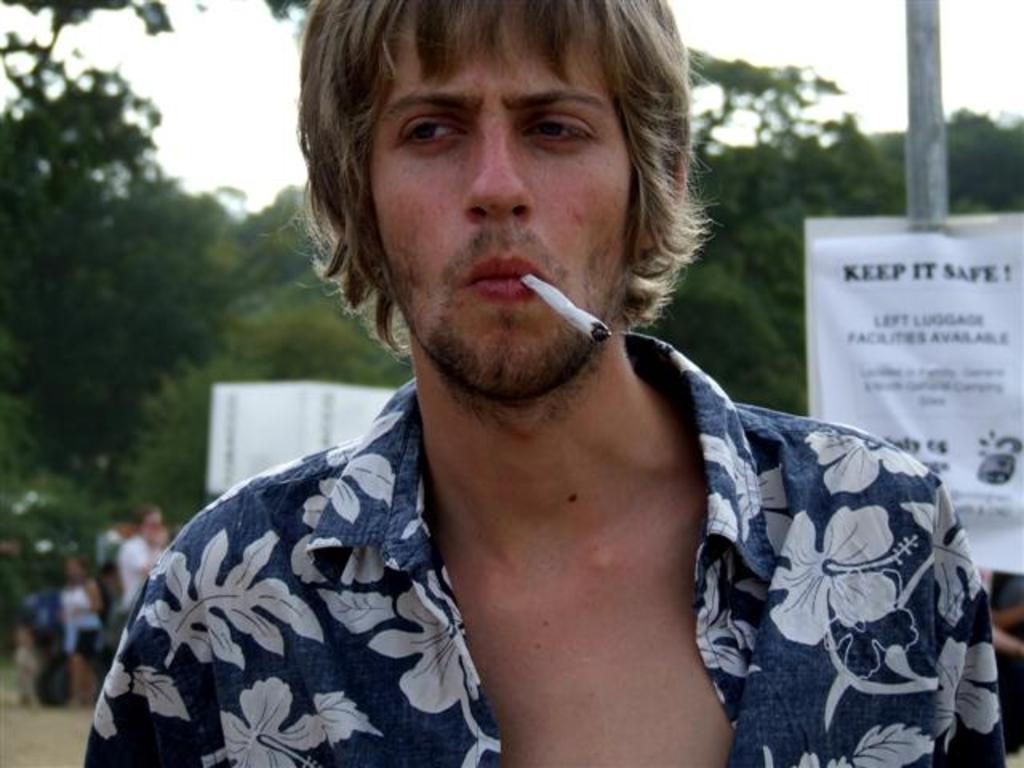Can you describe this image briefly? In this image we can see a man with cigarette in the mouth. In the background there are advertisement attached to the pole, trees, people standing on the road and sky. 